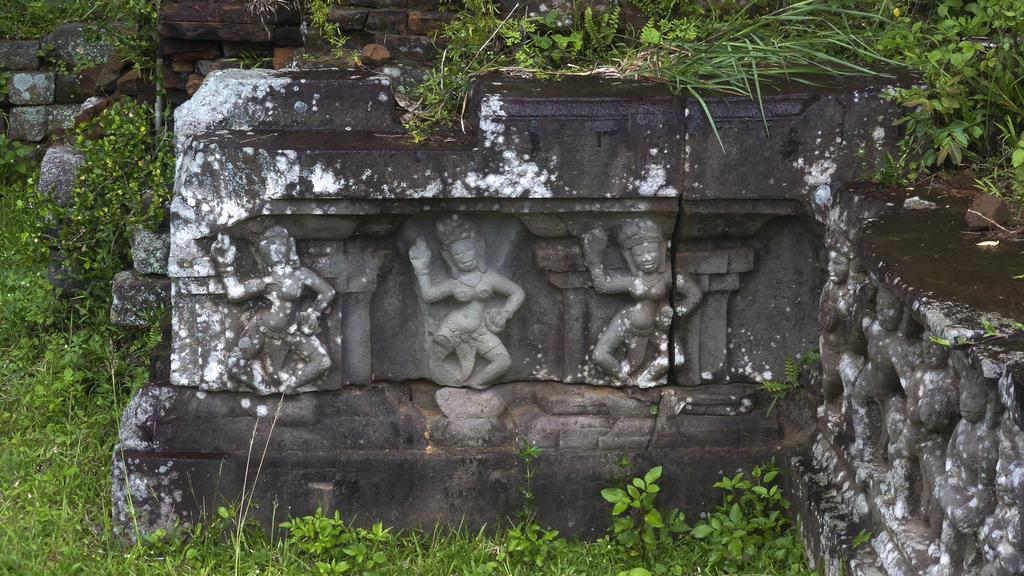What can be seen on the wall in the image? There are statues on the wall in the image. What type of living organisms are present in the image? There are plants in the image. What type of popcorn can be seen growing on the plants in the image? There is no popcorn present in the image; it is a picture of statues on the wall and plants. How many feet are visible in the image? There are no feet visible in the image. 